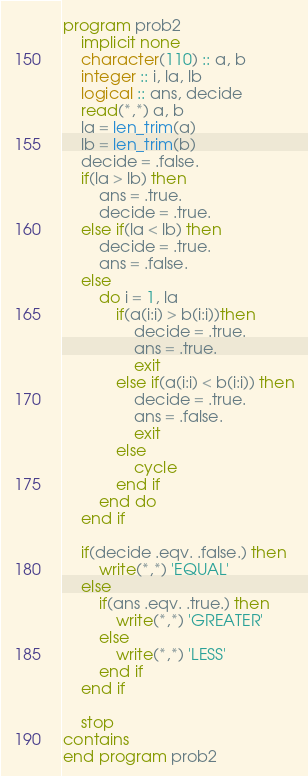<code> <loc_0><loc_0><loc_500><loc_500><_FORTRAN_>program prob2
    implicit none
    character(110) :: a, b
    integer :: i, la, lb
    logical :: ans, decide
    read(*,*) a, b
    la = len_trim(a)
    lb = len_trim(b)
    decide = .false.
    if(la > lb) then
        ans = .true.
        decide = .true.
    else if(la < lb) then
        decide = .true.
        ans = .false.
    else
        do i = 1, la
            if(a(i:i) > b(i:i))then
                decide = .true.
                ans = .true.
                exit
            else if(a(i:i) < b(i:i)) then
                decide = .true.
                ans = .false.
                exit
            else
                cycle
            end if
        end do
    end if

    if(decide .eqv. .false.) then
        write(*,*) 'EQUAL'
    else
        if(ans .eqv. .true.) then
            write(*,*) 'GREATER'
        else
            write(*,*) 'LESS'
        end if
    end if

    stop
contains
end program prob2</code> 